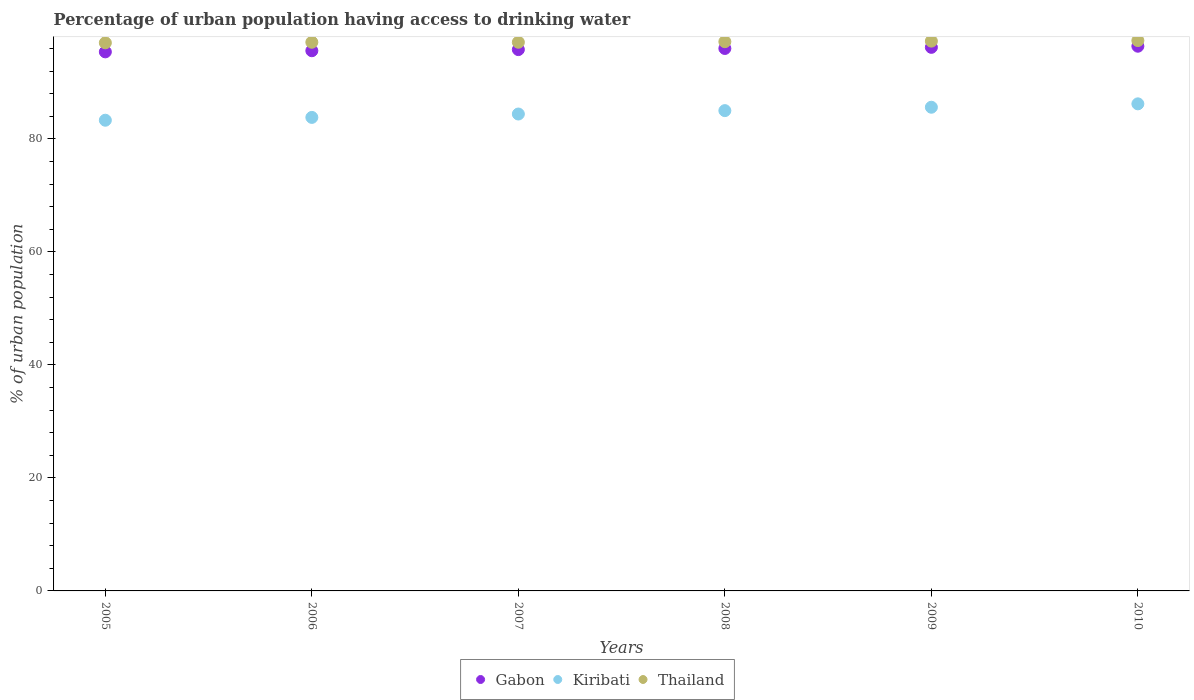What is the percentage of urban population having access to drinking water in Gabon in 2009?
Your response must be concise. 96.2. Across all years, what is the maximum percentage of urban population having access to drinking water in Kiribati?
Your answer should be compact. 86.2. Across all years, what is the minimum percentage of urban population having access to drinking water in Kiribati?
Offer a terse response. 83.3. In which year was the percentage of urban population having access to drinking water in Kiribati maximum?
Offer a very short reply. 2010. What is the total percentage of urban population having access to drinking water in Kiribati in the graph?
Make the answer very short. 508.3. What is the difference between the percentage of urban population having access to drinking water in Kiribati in 2005 and that in 2006?
Give a very brief answer. -0.5. What is the difference between the percentage of urban population having access to drinking water in Thailand in 2006 and the percentage of urban population having access to drinking water in Gabon in 2009?
Provide a succinct answer. 0.9. What is the average percentage of urban population having access to drinking water in Gabon per year?
Your response must be concise. 95.9. In the year 2009, what is the difference between the percentage of urban population having access to drinking water in Thailand and percentage of urban population having access to drinking water in Gabon?
Your answer should be compact. 1.1. What is the ratio of the percentage of urban population having access to drinking water in Gabon in 2007 to that in 2009?
Give a very brief answer. 1. Is the percentage of urban population having access to drinking water in Kiribati in 2008 less than that in 2010?
Your answer should be very brief. Yes. What is the difference between the highest and the second highest percentage of urban population having access to drinking water in Thailand?
Ensure brevity in your answer.  0.1. In how many years, is the percentage of urban population having access to drinking water in Thailand greater than the average percentage of urban population having access to drinking water in Thailand taken over all years?
Your response must be concise. 3. Does the percentage of urban population having access to drinking water in Thailand monotonically increase over the years?
Provide a short and direct response. No. Is the percentage of urban population having access to drinking water in Thailand strictly greater than the percentage of urban population having access to drinking water in Gabon over the years?
Offer a terse response. Yes. Is the percentage of urban population having access to drinking water in Gabon strictly less than the percentage of urban population having access to drinking water in Thailand over the years?
Provide a short and direct response. Yes. What is the difference between two consecutive major ticks on the Y-axis?
Provide a short and direct response. 20. Are the values on the major ticks of Y-axis written in scientific E-notation?
Provide a succinct answer. No. Where does the legend appear in the graph?
Your answer should be very brief. Bottom center. What is the title of the graph?
Keep it short and to the point. Percentage of urban population having access to drinking water. What is the label or title of the Y-axis?
Your answer should be compact. % of urban population. What is the % of urban population in Gabon in 2005?
Offer a very short reply. 95.4. What is the % of urban population in Kiribati in 2005?
Your answer should be compact. 83.3. What is the % of urban population in Thailand in 2005?
Offer a very short reply. 97. What is the % of urban population of Gabon in 2006?
Your answer should be very brief. 95.6. What is the % of urban population in Kiribati in 2006?
Provide a short and direct response. 83.8. What is the % of urban population in Thailand in 2006?
Your response must be concise. 97.1. What is the % of urban population of Gabon in 2007?
Your answer should be compact. 95.8. What is the % of urban population in Kiribati in 2007?
Ensure brevity in your answer.  84.4. What is the % of urban population in Thailand in 2007?
Your response must be concise. 97.1. What is the % of urban population in Gabon in 2008?
Provide a succinct answer. 96. What is the % of urban population in Kiribati in 2008?
Make the answer very short. 85. What is the % of urban population of Thailand in 2008?
Your answer should be compact. 97.2. What is the % of urban population in Gabon in 2009?
Give a very brief answer. 96.2. What is the % of urban population of Kiribati in 2009?
Provide a short and direct response. 85.6. What is the % of urban population of Thailand in 2009?
Keep it short and to the point. 97.3. What is the % of urban population in Gabon in 2010?
Your answer should be compact. 96.4. What is the % of urban population in Kiribati in 2010?
Your answer should be compact. 86.2. What is the % of urban population in Thailand in 2010?
Provide a short and direct response. 97.4. Across all years, what is the maximum % of urban population of Gabon?
Provide a short and direct response. 96.4. Across all years, what is the maximum % of urban population in Kiribati?
Give a very brief answer. 86.2. Across all years, what is the maximum % of urban population in Thailand?
Provide a succinct answer. 97.4. Across all years, what is the minimum % of urban population in Gabon?
Provide a short and direct response. 95.4. Across all years, what is the minimum % of urban population in Kiribati?
Keep it short and to the point. 83.3. Across all years, what is the minimum % of urban population of Thailand?
Offer a terse response. 97. What is the total % of urban population of Gabon in the graph?
Your answer should be compact. 575.4. What is the total % of urban population in Kiribati in the graph?
Provide a short and direct response. 508.3. What is the total % of urban population in Thailand in the graph?
Provide a short and direct response. 583.1. What is the difference between the % of urban population in Kiribati in 2005 and that in 2007?
Provide a short and direct response. -1.1. What is the difference between the % of urban population of Thailand in 2005 and that in 2007?
Provide a succinct answer. -0.1. What is the difference between the % of urban population in Gabon in 2005 and that in 2008?
Provide a succinct answer. -0.6. What is the difference between the % of urban population in Kiribati in 2005 and that in 2009?
Make the answer very short. -2.3. What is the difference between the % of urban population in Thailand in 2005 and that in 2009?
Ensure brevity in your answer.  -0.3. What is the difference between the % of urban population in Kiribati in 2005 and that in 2010?
Provide a succinct answer. -2.9. What is the difference between the % of urban population of Gabon in 2006 and that in 2007?
Your response must be concise. -0.2. What is the difference between the % of urban population of Kiribati in 2006 and that in 2007?
Keep it short and to the point. -0.6. What is the difference between the % of urban population of Thailand in 2006 and that in 2007?
Give a very brief answer. 0. What is the difference between the % of urban population of Kiribati in 2006 and that in 2008?
Offer a terse response. -1.2. What is the difference between the % of urban population in Gabon in 2006 and that in 2009?
Your answer should be very brief. -0.6. What is the difference between the % of urban population in Kiribati in 2006 and that in 2009?
Provide a succinct answer. -1.8. What is the difference between the % of urban population of Thailand in 2006 and that in 2010?
Make the answer very short. -0.3. What is the difference between the % of urban population in Kiribati in 2007 and that in 2008?
Provide a short and direct response. -0.6. What is the difference between the % of urban population in Thailand in 2007 and that in 2008?
Provide a short and direct response. -0.1. What is the difference between the % of urban population in Kiribati in 2007 and that in 2009?
Keep it short and to the point. -1.2. What is the difference between the % of urban population of Thailand in 2007 and that in 2009?
Ensure brevity in your answer.  -0.2. What is the difference between the % of urban population in Gabon in 2007 and that in 2010?
Give a very brief answer. -0.6. What is the difference between the % of urban population in Kiribati in 2007 and that in 2010?
Provide a short and direct response. -1.8. What is the difference between the % of urban population of Thailand in 2007 and that in 2010?
Keep it short and to the point. -0.3. What is the difference between the % of urban population of Kiribati in 2008 and that in 2009?
Your answer should be compact. -0.6. What is the difference between the % of urban population in Kiribati in 2008 and that in 2010?
Ensure brevity in your answer.  -1.2. What is the difference between the % of urban population of Thailand in 2008 and that in 2010?
Ensure brevity in your answer.  -0.2. What is the difference between the % of urban population in Thailand in 2009 and that in 2010?
Offer a terse response. -0.1. What is the difference between the % of urban population in Gabon in 2005 and the % of urban population in Thailand in 2006?
Offer a terse response. -1.7. What is the difference between the % of urban population of Kiribati in 2005 and the % of urban population of Thailand in 2006?
Offer a very short reply. -13.8. What is the difference between the % of urban population of Gabon in 2005 and the % of urban population of Kiribati in 2008?
Your answer should be compact. 10.4. What is the difference between the % of urban population of Gabon in 2005 and the % of urban population of Thailand in 2009?
Make the answer very short. -1.9. What is the difference between the % of urban population in Kiribati in 2005 and the % of urban population in Thailand in 2009?
Give a very brief answer. -14. What is the difference between the % of urban population of Gabon in 2005 and the % of urban population of Kiribati in 2010?
Make the answer very short. 9.2. What is the difference between the % of urban population in Kiribati in 2005 and the % of urban population in Thailand in 2010?
Give a very brief answer. -14.1. What is the difference between the % of urban population in Gabon in 2006 and the % of urban population in Kiribati in 2007?
Your answer should be very brief. 11.2. What is the difference between the % of urban population of Gabon in 2006 and the % of urban population of Thailand in 2007?
Make the answer very short. -1.5. What is the difference between the % of urban population in Kiribati in 2006 and the % of urban population in Thailand in 2008?
Offer a terse response. -13.4. What is the difference between the % of urban population of Gabon in 2006 and the % of urban population of Kiribati in 2009?
Your answer should be compact. 10. What is the difference between the % of urban population in Gabon in 2006 and the % of urban population in Thailand in 2009?
Offer a very short reply. -1.7. What is the difference between the % of urban population in Kiribati in 2006 and the % of urban population in Thailand in 2009?
Your answer should be compact. -13.5. What is the difference between the % of urban population in Gabon in 2006 and the % of urban population in Thailand in 2010?
Provide a succinct answer. -1.8. What is the difference between the % of urban population of Gabon in 2007 and the % of urban population of Kiribati in 2008?
Provide a short and direct response. 10.8. What is the difference between the % of urban population in Gabon in 2007 and the % of urban population in Thailand in 2008?
Your answer should be compact. -1.4. What is the difference between the % of urban population of Kiribati in 2007 and the % of urban population of Thailand in 2009?
Your response must be concise. -12.9. What is the difference between the % of urban population in Kiribati in 2007 and the % of urban population in Thailand in 2010?
Provide a short and direct response. -13. What is the difference between the % of urban population of Gabon in 2008 and the % of urban population of Kiribati in 2009?
Provide a succinct answer. 10.4. What is the difference between the % of urban population in Gabon in 2008 and the % of urban population in Thailand in 2009?
Provide a succinct answer. -1.3. What is the difference between the % of urban population of Kiribati in 2008 and the % of urban population of Thailand in 2009?
Keep it short and to the point. -12.3. What is the difference between the % of urban population in Gabon in 2008 and the % of urban population in Kiribati in 2010?
Offer a terse response. 9.8. What is the difference between the % of urban population in Kiribati in 2008 and the % of urban population in Thailand in 2010?
Your answer should be compact. -12.4. What is the difference between the % of urban population of Gabon in 2009 and the % of urban population of Thailand in 2010?
Your answer should be compact. -1.2. What is the average % of urban population of Gabon per year?
Provide a short and direct response. 95.9. What is the average % of urban population in Kiribati per year?
Offer a terse response. 84.72. What is the average % of urban population in Thailand per year?
Your answer should be compact. 97.18. In the year 2005, what is the difference between the % of urban population of Gabon and % of urban population of Kiribati?
Offer a terse response. 12.1. In the year 2005, what is the difference between the % of urban population of Kiribati and % of urban population of Thailand?
Keep it short and to the point. -13.7. In the year 2006, what is the difference between the % of urban population in Gabon and % of urban population in Kiribati?
Offer a terse response. 11.8. In the year 2006, what is the difference between the % of urban population in Gabon and % of urban population in Thailand?
Ensure brevity in your answer.  -1.5. In the year 2007, what is the difference between the % of urban population in Gabon and % of urban population in Kiribati?
Your answer should be compact. 11.4. In the year 2008, what is the difference between the % of urban population of Gabon and % of urban population of Kiribati?
Provide a succinct answer. 11. In the year 2008, what is the difference between the % of urban population in Gabon and % of urban population in Thailand?
Offer a terse response. -1.2. In the year 2009, what is the difference between the % of urban population in Gabon and % of urban population in Thailand?
Your response must be concise. -1.1. In the year 2010, what is the difference between the % of urban population in Gabon and % of urban population in Kiribati?
Provide a succinct answer. 10.2. What is the ratio of the % of urban population of Gabon in 2005 to that in 2006?
Provide a succinct answer. 1. What is the ratio of the % of urban population of Kiribati in 2005 to that in 2006?
Offer a terse response. 0.99. What is the ratio of the % of urban population of Thailand in 2005 to that in 2006?
Provide a short and direct response. 1. What is the ratio of the % of urban population in Gabon in 2005 to that in 2007?
Your answer should be compact. 1. What is the ratio of the % of urban population of Kiribati in 2005 to that in 2008?
Offer a terse response. 0.98. What is the ratio of the % of urban population in Kiribati in 2005 to that in 2009?
Provide a succinct answer. 0.97. What is the ratio of the % of urban population in Gabon in 2005 to that in 2010?
Ensure brevity in your answer.  0.99. What is the ratio of the % of urban population of Kiribati in 2005 to that in 2010?
Give a very brief answer. 0.97. What is the ratio of the % of urban population in Thailand in 2006 to that in 2007?
Ensure brevity in your answer.  1. What is the ratio of the % of urban population in Kiribati in 2006 to that in 2008?
Provide a short and direct response. 0.99. What is the ratio of the % of urban population of Gabon in 2006 to that in 2009?
Your answer should be very brief. 0.99. What is the ratio of the % of urban population in Gabon in 2006 to that in 2010?
Your answer should be very brief. 0.99. What is the ratio of the % of urban population of Kiribati in 2006 to that in 2010?
Make the answer very short. 0.97. What is the ratio of the % of urban population in Thailand in 2006 to that in 2010?
Your answer should be compact. 1. What is the ratio of the % of urban population of Thailand in 2007 to that in 2008?
Keep it short and to the point. 1. What is the ratio of the % of urban population in Gabon in 2007 to that in 2009?
Your response must be concise. 1. What is the ratio of the % of urban population of Thailand in 2007 to that in 2009?
Keep it short and to the point. 1. What is the ratio of the % of urban population of Gabon in 2007 to that in 2010?
Provide a succinct answer. 0.99. What is the ratio of the % of urban population of Kiribati in 2007 to that in 2010?
Keep it short and to the point. 0.98. What is the ratio of the % of urban population in Thailand in 2008 to that in 2009?
Your answer should be very brief. 1. What is the ratio of the % of urban population of Kiribati in 2008 to that in 2010?
Provide a short and direct response. 0.99. What is the ratio of the % of urban population of Kiribati in 2009 to that in 2010?
Provide a succinct answer. 0.99. What is the difference between the highest and the second highest % of urban population in Gabon?
Give a very brief answer. 0.2. What is the difference between the highest and the lowest % of urban population in Kiribati?
Make the answer very short. 2.9. What is the difference between the highest and the lowest % of urban population in Thailand?
Keep it short and to the point. 0.4. 